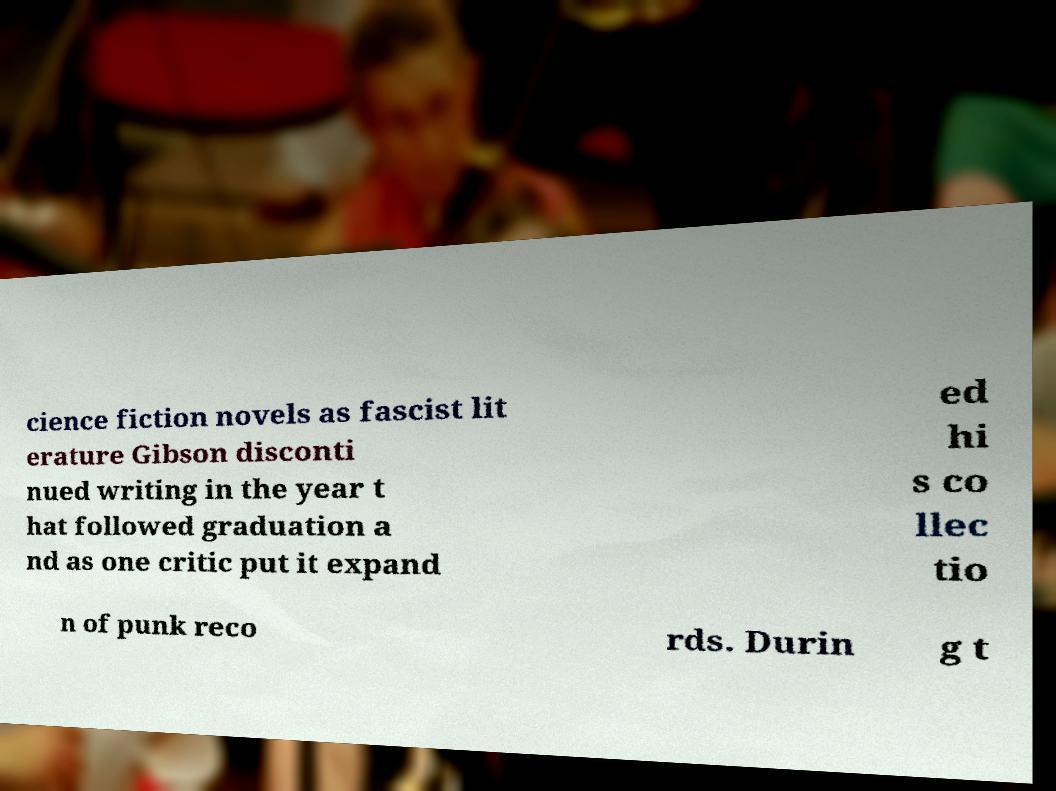Can you read and provide the text displayed in the image?This photo seems to have some interesting text. Can you extract and type it out for me? cience fiction novels as fascist lit erature Gibson disconti nued writing in the year t hat followed graduation a nd as one critic put it expand ed hi s co llec tio n of punk reco rds. Durin g t 